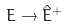Convert formula to latex. <formula><loc_0><loc_0><loc_500><loc_500>E \rightarrow \hat { E } ^ { + }</formula> 